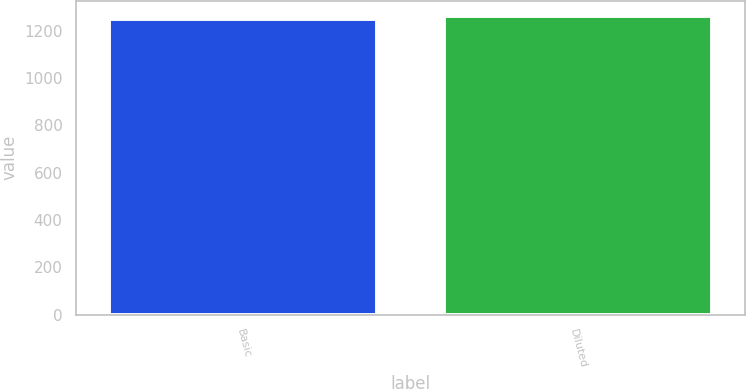<chart> <loc_0><loc_0><loc_500><loc_500><bar_chart><fcel>Basic<fcel>Diluted<nl><fcel>1250<fcel>1263<nl></chart> 